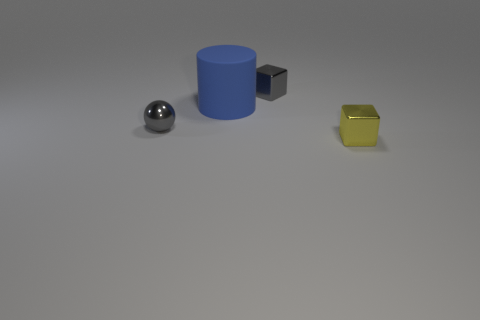Add 2 small yellow metal objects. How many objects exist? 6 Subtract all spheres. How many objects are left? 3 Subtract all small things. Subtract all tiny gray metal blocks. How many objects are left? 0 Add 2 tiny gray shiny cubes. How many tiny gray shiny cubes are left? 3 Add 4 gray metal spheres. How many gray metal spheres exist? 5 Subtract 1 gray cubes. How many objects are left? 3 